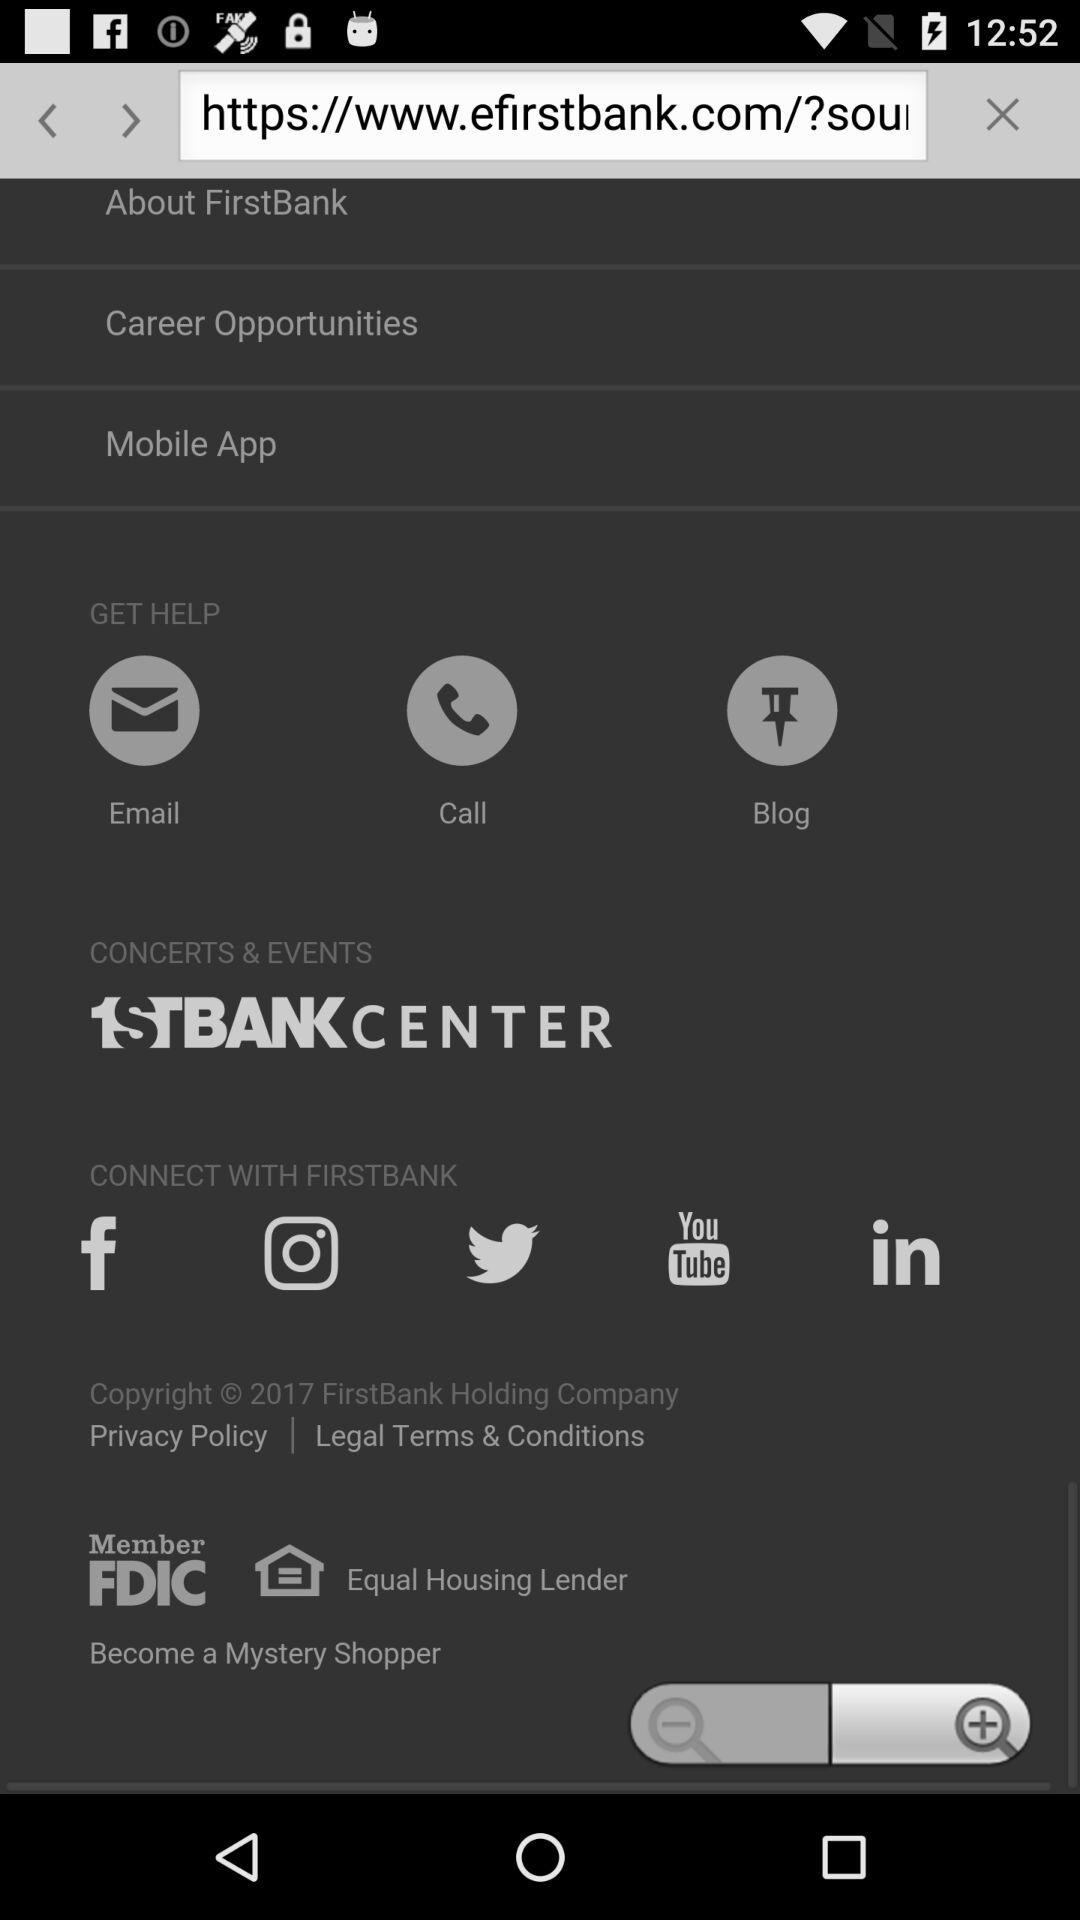How many different contact methods are available?
Answer the question using a single word or phrase. 3 